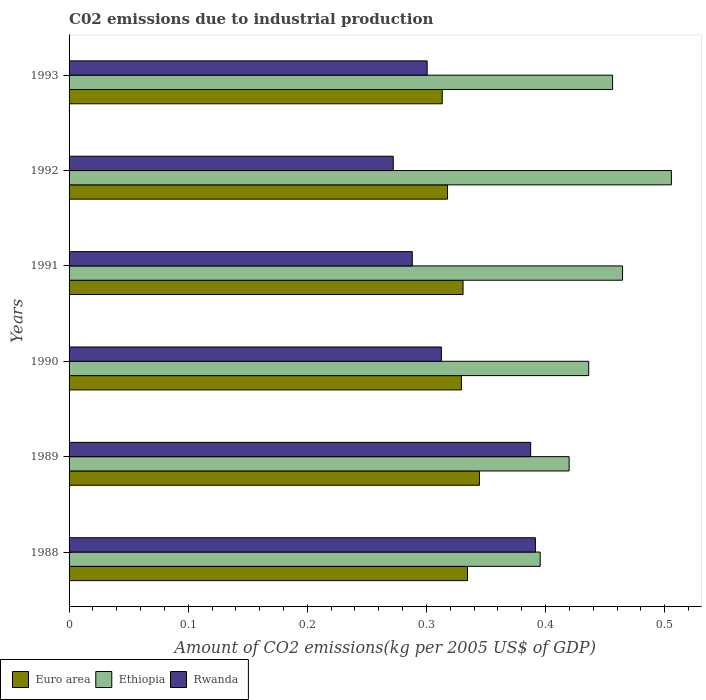How many groups of bars are there?
Provide a succinct answer. 6. Are the number of bars per tick equal to the number of legend labels?
Your answer should be very brief. Yes. Are the number of bars on each tick of the Y-axis equal?
Give a very brief answer. Yes. In how many cases, is the number of bars for a given year not equal to the number of legend labels?
Keep it short and to the point. 0. What is the amount of CO2 emitted due to industrial production in Euro area in 1992?
Offer a very short reply. 0.32. Across all years, what is the maximum amount of CO2 emitted due to industrial production in Rwanda?
Provide a succinct answer. 0.39. Across all years, what is the minimum amount of CO2 emitted due to industrial production in Euro area?
Your answer should be compact. 0.31. In which year was the amount of CO2 emitted due to industrial production in Ethiopia minimum?
Give a very brief answer. 1988. What is the total amount of CO2 emitted due to industrial production in Ethiopia in the graph?
Ensure brevity in your answer.  2.68. What is the difference between the amount of CO2 emitted due to industrial production in Ethiopia in 1989 and that in 1991?
Your response must be concise. -0.04. What is the difference between the amount of CO2 emitted due to industrial production in Ethiopia in 1991 and the amount of CO2 emitted due to industrial production in Euro area in 1989?
Your response must be concise. 0.12. What is the average amount of CO2 emitted due to industrial production in Euro area per year?
Keep it short and to the point. 0.33. In the year 1989, what is the difference between the amount of CO2 emitted due to industrial production in Euro area and amount of CO2 emitted due to industrial production in Rwanda?
Provide a succinct answer. -0.04. What is the ratio of the amount of CO2 emitted due to industrial production in Ethiopia in 1988 to that in 1991?
Provide a short and direct response. 0.85. Is the amount of CO2 emitted due to industrial production in Ethiopia in 1988 less than that in 1989?
Offer a very short reply. Yes. Is the difference between the amount of CO2 emitted due to industrial production in Euro area in 1988 and 1991 greater than the difference between the amount of CO2 emitted due to industrial production in Rwanda in 1988 and 1991?
Provide a succinct answer. No. What is the difference between the highest and the second highest amount of CO2 emitted due to industrial production in Rwanda?
Offer a terse response. 0. What is the difference between the highest and the lowest amount of CO2 emitted due to industrial production in Euro area?
Ensure brevity in your answer.  0.03. In how many years, is the amount of CO2 emitted due to industrial production in Ethiopia greater than the average amount of CO2 emitted due to industrial production in Ethiopia taken over all years?
Make the answer very short. 3. What does the 2nd bar from the bottom in 1989 represents?
Give a very brief answer. Ethiopia. Is it the case that in every year, the sum of the amount of CO2 emitted due to industrial production in Rwanda and amount of CO2 emitted due to industrial production in Ethiopia is greater than the amount of CO2 emitted due to industrial production in Euro area?
Ensure brevity in your answer.  Yes. How many bars are there?
Ensure brevity in your answer.  18. What is the difference between two consecutive major ticks on the X-axis?
Give a very brief answer. 0.1. Does the graph contain any zero values?
Provide a succinct answer. No. Does the graph contain grids?
Offer a very short reply. No. Where does the legend appear in the graph?
Offer a terse response. Bottom left. How many legend labels are there?
Provide a succinct answer. 3. What is the title of the graph?
Make the answer very short. C02 emissions due to industrial production. What is the label or title of the X-axis?
Your answer should be very brief. Amount of CO2 emissions(kg per 2005 US$ of GDP). What is the label or title of the Y-axis?
Offer a very short reply. Years. What is the Amount of CO2 emissions(kg per 2005 US$ of GDP) of Euro area in 1988?
Provide a short and direct response. 0.33. What is the Amount of CO2 emissions(kg per 2005 US$ of GDP) of Ethiopia in 1988?
Make the answer very short. 0.4. What is the Amount of CO2 emissions(kg per 2005 US$ of GDP) in Rwanda in 1988?
Give a very brief answer. 0.39. What is the Amount of CO2 emissions(kg per 2005 US$ of GDP) in Euro area in 1989?
Make the answer very short. 0.34. What is the Amount of CO2 emissions(kg per 2005 US$ of GDP) of Ethiopia in 1989?
Provide a succinct answer. 0.42. What is the Amount of CO2 emissions(kg per 2005 US$ of GDP) of Rwanda in 1989?
Provide a succinct answer. 0.39. What is the Amount of CO2 emissions(kg per 2005 US$ of GDP) in Euro area in 1990?
Your answer should be compact. 0.33. What is the Amount of CO2 emissions(kg per 2005 US$ of GDP) in Ethiopia in 1990?
Provide a succinct answer. 0.44. What is the Amount of CO2 emissions(kg per 2005 US$ of GDP) of Rwanda in 1990?
Offer a terse response. 0.31. What is the Amount of CO2 emissions(kg per 2005 US$ of GDP) of Euro area in 1991?
Keep it short and to the point. 0.33. What is the Amount of CO2 emissions(kg per 2005 US$ of GDP) in Ethiopia in 1991?
Provide a succinct answer. 0.46. What is the Amount of CO2 emissions(kg per 2005 US$ of GDP) of Rwanda in 1991?
Provide a short and direct response. 0.29. What is the Amount of CO2 emissions(kg per 2005 US$ of GDP) in Euro area in 1992?
Make the answer very short. 0.32. What is the Amount of CO2 emissions(kg per 2005 US$ of GDP) of Ethiopia in 1992?
Your answer should be compact. 0.51. What is the Amount of CO2 emissions(kg per 2005 US$ of GDP) of Rwanda in 1992?
Keep it short and to the point. 0.27. What is the Amount of CO2 emissions(kg per 2005 US$ of GDP) of Euro area in 1993?
Offer a terse response. 0.31. What is the Amount of CO2 emissions(kg per 2005 US$ of GDP) of Ethiopia in 1993?
Your response must be concise. 0.46. What is the Amount of CO2 emissions(kg per 2005 US$ of GDP) of Rwanda in 1993?
Your response must be concise. 0.3. Across all years, what is the maximum Amount of CO2 emissions(kg per 2005 US$ of GDP) in Euro area?
Your answer should be compact. 0.34. Across all years, what is the maximum Amount of CO2 emissions(kg per 2005 US$ of GDP) of Ethiopia?
Provide a succinct answer. 0.51. Across all years, what is the maximum Amount of CO2 emissions(kg per 2005 US$ of GDP) of Rwanda?
Provide a short and direct response. 0.39. Across all years, what is the minimum Amount of CO2 emissions(kg per 2005 US$ of GDP) in Euro area?
Your response must be concise. 0.31. Across all years, what is the minimum Amount of CO2 emissions(kg per 2005 US$ of GDP) of Ethiopia?
Provide a short and direct response. 0.4. Across all years, what is the minimum Amount of CO2 emissions(kg per 2005 US$ of GDP) in Rwanda?
Your answer should be compact. 0.27. What is the total Amount of CO2 emissions(kg per 2005 US$ of GDP) of Euro area in the graph?
Provide a succinct answer. 1.97. What is the total Amount of CO2 emissions(kg per 2005 US$ of GDP) of Ethiopia in the graph?
Offer a terse response. 2.68. What is the total Amount of CO2 emissions(kg per 2005 US$ of GDP) in Rwanda in the graph?
Keep it short and to the point. 1.95. What is the difference between the Amount of CO2 emissions(kg per 2005 US$ of GDP) of Euro area in 1988 and that in 1989?
Provide a succinct answer. -0.01. What is the difference between the Amount of CO2 emissions(kg per 2005 US$ of GDP) of Ethiopia in 1988 and that in 1989?
Give a very brief answer. -0.02. What is the difference between the Amount of CO2 emissions(kg per 2005 US$ of GDP) in Rwanda in 1988 and that in 1989?
Make the answer very short. 0. What is the difference between the Amount of CO2 emissions(kg per 2005 US$ of GDP) of Euro area in 1988 and that in 1990?
Ensure brevity in your answer.  0.01. What is the difference between the Amount of CO2 emissions(kg per 2005 US$ of GDP) of Ethiopia in 1988 and that in 1990?
Offer a terse response. -0.04. What is the difference between the Amount of CO2 emissions(kg per 2005 US$ of GDP) in Rwanda in 1988 and that in 1990?
Offer a terse response. 0.08. What is the difference between the Amount of CO2 emissions(kg per 2005 US$ of GDP) of Euro area in 1988 and that in 1991?
Your answer should be compact. 0. What is the difference between the Amount of CO2 emissions(kg per 2005 US$ of GDP) in Ethiopia in 1988 and that in 1991?
Provide a succinct answer. -0.07. What is the difference between the Amount of CO2 emissions(kg per 2005 US$ of GDP) of Rwanda in 1988 and that in 1991?
Offer a terse response. 0.1. What is the difference between the Amount of CO2 emissions(kg per 2005 US$ of GDP) in Euro area in 1988 and that in 1992?
Your answer should be compact. 0.02. What is the difference between the Amount of CO2 emissions(kg per 2005 US$ of GDP) of Ethiopia in 1988 and that in 1992?
Provide a succinct answer. -0.11. What is the difference between the Amount of CO2 emissions(kg per 2005 US$ of GDP) of Rwanda in 1988 and that in 1992?
Provide a succinct answer. 0.12. What is the difference between the Amount of CO2 emissions(kg per 2005 US$ of GDP) in Euro area in 1988 and that in 1993?
Keep it short and to the point. 0.02. What is the difference between the Amount of CO2 emissions(kg per 2005 US$ of GDP) of Ethiopia in 1988 and that in 1993?
Your answer should be very brief. -0.06. What is the difference between the Amount of CO2 emissions(kg per 2005 US$ of GDP) in Rwanda in 1988 and that in 1993?
Your answer should be compact. 0.09. What is the difference between the Amount of CO2 emissions(kg per 2005 US$ of GDP) in Euro area in 1989 and that in 1990?
Your response must be concise. 0.02. What is the difference between the Amount of CO2 emissions(kg per 2005 US$ of GDP) of Ethiopia in 1989 and that in 1990?
Provide a short and direct response. -0.02. What is the difference between the Amount of CO2 emissions(kg per 2005 US$ of GDP) in Rwanda in 1989 and that in 1990?
Your answer should be very brief. 0.07. What is the difference between the Amount of CO2 emissions(kg per 2005 US$ of GDP) of Euro area in 1989 and that in 1991?
Ensure brevity in your answer.  0.01. What is the difference between the Amount of CO2 emissions(kg per 2005 US$ of GDP) of Ethiopia in 1989 and that in 1991?
Provide a short and direct response. -0.04. What is the difference between the Amount of CO2 emissions(kg per 2005 US$ of GDP) of Rwanda in 1989 and that in 1991?
Ensure brevity in your answer.  0.1. What is the difference between the Amount of CO2 emissions(kg per 2005 US$ of GDP) in Euro area in 1989 and that in 1992?
Provide a short and direct response. 0.03. What is the difference between the Amount of CO2 emissions(kg per 2005 US$ of GDP) of Ethiopia in 1989 and that in 1992?
Give a very brief answer. -0.09. What is the difference between the Amount of CO2 emissions(kg per 2005 US$ of GDP) in Rwanda in 1989 and that in 1992?
Offer a very short reply. 0.12. What is the difference between the Amount of CO2 emissions(kg per 2005 US$ of GDP) of Euro area in 1989 and that in 1993?
Your answer should be very brief. 0.03. What is the difference between the Amount of CO2 emissions(kg per 2005 US$ of GDP) in Ethiopia in 1989 and that in 1993?
Your response must be concise. -0.04. What is the difference between the Amount of CO2 emissions(kg per 2005 US$ of GDP) in Rwanda in 1989 and that in 1993?
Offer a very short reply. 0.09. What is the difference between the Amount of CO2 emissions(kg per 2005 US$ of GDP) of Euro area in 1990 and that in 1991?
Make the answer very short. -0. What is the difference between the Amount of CO2 emissions(kg per 2005 US$ of GDP) in Ethiopia in 1990 and that in 1991?
Provide a short and direct response. -0.03. What is the difference between the Amount of CO2 emissions(kg per 2005 US$ of GDP) in Rwanda in 1990 and that in 1991?
Ensure brevity in your answer.  0.02. What is the difference between the Amount of CO2 emissions(kg per 2005 US$ of GDP) of Euro area in 1990 and that in 1992?
Provide a succinct answer. 0.01. What is the difference between the Amount of CO2 emissions(kg per 2005 US$ of GDP) in Ethiopia in 1990 and that in 1992?
Give a very brief answer. -0.07. What is the difference between the Amount of CO2 emissions(kg per 2005 US$ of GDP) in Rwanda in 1990 and that in 1992?
Keep it short and to the point. 0.04. What is the difference between the Amount of CO2 emissions(kg per 2005 US$ of GDP) of Euro area in 1990 and that in 1993?
Keep it short and to the point. 0.02. What is the difference between the Amount of CO2 emissions(kg per 2005 US$ of GDP) of Ethiopia in 1990 and that in 1993?
Offer a very short reply. -0.02. What is the difference between the Amount of CO2 emissions(kg per 2005 US$ of GDP) in Rwanda in 1990 and that in 1993?
Provide a succinct answer. 0.01. What is the difference between the Amount of CO2 emissions(kg per 2005 US$ of GDP) in Euro area in 1991 and that in 1992?
Offer a very short reply. 0.01. What is the difference between the Amount of CO2 emissions(kg per 2005 US$ of GDP) of Ethiopia in 1991 and that in 1992?
Provide a short and direct response. -0.04. What is the difference between the Amount of CO2 emissions(kg per 2005 US$ of GDP) of Rwanda in 1991 and that in 1992?
Make the answer very short. 0.02. What is the difference between the Amount of CO2 emissions(kg per 2005 US$ of GDP) of Euro area in 1991 and that in 1993?
Offer a terse response. 0.02. What is the difference between the Amount of CO2 emissions(kg per 2005 US$ of GDP) of Ethiopia in 1991 and that in 1993?
Provide a short and direct response. 0.01. What is the difference between the Amount of CO2 emissions(kg per 2005 US$ of GDP) in Rwanda in 1991 and that in 1993?
Provide a succinct answer. -0.01. What is the difference between the Amount of CO2 emissions(kg per 2005 US$ of GDP) of Euro area in 1992 and that in 1993?
Ensure brevity in your answer.  0. What is the difference between the Amount of CO2 emissions(kg per 2005 US$ of GDP) in Ethiopia in 1992 and that in 1993?
Provide a succinct answer. 0.05. What is the difference between the Amount of CO2 emissions(kg per 2005 US$ of GDP) of Rwanda in 1992 and that in 1993?
Your response must be concise. -0.03. What is the difference between the Amount of CO2 emissions(kg per 2005 US$ of GDP) of Euro area in 1988 and the Amount of CO2 emissions(kg per 2005 US$ of GDP) of Ethiopia in 1989?
Provide a short and direct response. -0.09. What is the difference between the Amount of CO2 emissions(kg per 2005 US$ of GDP) of Euro area in 1988 and the Amount of CO2 emissions(kg per 2005 US$ of GDP) of Rwanda in 1989?
Give a very brief answer. -0.05. What is the difference between the Amount of CO2 emissions(kg per 2005 US$ of GDP) of Ethiopia in 1988 and the Amount of CO2 emissions(kg per 2005 US$ of GDP) of Rwanda in 1989?
Your response must be concise. 0.01. What is the difference between the Amount of CO2 emissions(kg per 2005 US$ of GDP) in Euro area in 1988 and the Amount of CO2 emissions(kg per 2005 US$ of GDP) in Ethiopia in 1990?
Provide a succinct answer. -0.1. What is the difference between the Amount of CO2 emissions(kg per 2005 US$ of GDP) in Euro area in 1988 and the Amount of CO2 emissions(kg per 2005 US$ of GDP) in Rwanda in 1990?
Offer a very short reply. 0.02. What is the difference between the Amount of CO2 emissions(kg per 2005 US$ of GDP) in Ethiopia in 1988 and the Amount of CO2 emissions(kg per 2005 US$ of GDP) in Rwanda in 1990?
Offer a very short reply. 0.08. What is the difference between the Amount of CO2 emissions(kg per 2005 US$ of GDP) in Euro area in 1988 and the Amount of CO2 emissions(kg per 2005 US$ of GDP) in Ethiopia in 1991?
Offer a very short reply. -0.13. What is the difference between the Amount of CO2 emissions(kg per 2005 US$ of GDP) in Euro area in 1988 and the Amount of CO2 emissions(kg per 2005 US$ of GDP) in Rwanda in 1991?
Make the answer very short. 0.05. What is the difference between the Amount of CO2 emissions(kg per 2005 US$ of GDP) in Ethiopia in 1988 and the Amount of CO2 emissions(kg per 2005 US$ of GDP) in Rwanda in 1991?
Provide a short and direct response. 0.11. What is the difference between the Amount of CO2 emissions(kg per 2005 US$ of GDP) of Euro area in 1988 and the Amount of CO2 emissions(kg per 2005 US$ of GDP) of Ethiopia in 1992?
Provide a short and direct response. -0.17. What is the difference between the Amount of CO2 emissions(kg per 2005 US$ of GDP) in Euro area in 1988 and the Amount of CO2 emissions(kg per 2005 US$ of GDP) in Rwanda in 1992?
Your response must be concise. 0.06. What is the difference between the Amount of CO2 emissions(kg per 2005 US$ of GDP) in Ethiopia in 1988 and the Amount of CO2 emissions(kg per 2005 US$ of GDP) in Rwanda in 1992?
Provide a succinct answer. 0.12. What is the difference between the Amount of CO2 emissions(kg per 2005 US$ of GDP) in Euro area in 1988 and the Amount of CO2 emissions(kg per 2005 US$ of GDP) in Ethiopia in 1993?
Your answer should be very brief. -0.12. What is the difference between the Amount of CO2 emissions(kg per 2005 US$ of GDP) in Euro area in 1988 and the Amount of CO2 emissions(kg per 2005 US$ of GDP) in Rwanda in 1993?
Offer a terse response. 0.03. What is the difference between the Amount of CO2 emissions(kg per 2005 US$ of GDP) in Ethiopia in 1988 and the Amount of CO2 emissions(kg per 2005 US$ of GDP) in Rwanda in 1993?
Offer a terse response. 0.09. What is the difference between the Amount of CO2 emissions(kg per 2005 US$ of GDP) of Euro area in 1989 and the Amount of CO2 emissions(kg per 2005 US$ of GDP) of Ethiopia in 1990?
Your answer should be compact. -0.09. What is the difference between the Amount of CO2 emissions(kg per 2005 US$ of GDP) in Euro area in 1989 and the Amount of CO2 emissions(kg per 2005 US$ of GDP) in Rwanda in 1990?
Make the answer very short. 0.03. What is the difference between the Amount of CO2 emissions(kg per 2005 US$ of GDP) in Ethiopia in 1989 and the Amount of CO2 emissions(kg per 2005 US$ of GDP) in Rwanda in 1990?
Provide a short and direct response. 0.11. What is the difference between the Amount of CO2 emissions(kg per 2005 US$ of GDP) in Euro area in 1989 and the Amount of CO2 emissions(kg per 2005 US$ of GDP) in Ethiopia in 1991?
Your answer should be very brief. -0.12. What is the difference between the Amount of CO2 emissions(kg per 2005 US$ of GDP) in Euro area in 1989 and the Amount of CO2 emissions(kg per 2005 US$ of GDP) in Rwanda in 1991?
Your answer should be very brief. 0.06. What is the difference between the Amount of CO2 emissions(kg per 2005 US$ of GDP) in Ethiopia in 1989 and the Amount of CO2 emissions(kg per 2005 US$ of GDP) in Rwanda in 1991?
Your response must be concise. 0.13. What is the difference between the Amount of CO2 emissions(kg per 2005 US$ of GDP) of Euro area in 1989 and the Amount of CO2 emissions(kg per 2005 US$ of GDP) of Ethiopia in 1992?
Give a very brief answer. -0.16. What is the difference between the Amount of CO2 emissions(kg per 2005 US$ of GDP) of Euro area in 1989 and the Amount of CO2 emissions(kg per 2005 US$ of GDP) of Rwanda in 1992?
Your response must be concise. 0.07. What is the difference between the Amount of CO2 emissions(kg per 2005 US$ of GDP) in Ethiopia in 1989 and the Amount of CO2 emissions(kg per 2005 US$ of GDP) in Rwanda in 1992?
Offer a very short reply. 0.15. What is the difference between the Amount of CO2 emissions(kg per 2005 US$ of GDP) in Euro area in 1989 and the Amount of CO2 emissions(kg per 2005 US$ of GDP) in Ethiopia in 1993?
Keep it short and to the point. -0.11. What is the difference between the Amount of CO2 emissions(kg per 2005 US$ of GDP) of Euro area in 1989 and the Amount of CO2 emissions(kg per 2005 US$ of GDP) of Rwanda in 1993?
Your response must be concise. 0.04. What is the difference between the Amount of CO2 emissions(kg per 2005 US$ of GDP) in Ethiopia in 1989 and the Amount of CO2 emissions(kg per 2005 US$ of GDP) in Rwanda in 1993?
Your response must be concise. 0.12. What is the difference between the Amount of CO2 emissions(kg per 2005 US$ of GDP) of Euro area in 1990 and the Amount of CO2 emissions(kg per 2005 US$ of GDP) of Ethiopia in 1991?
Ensure brevity in your answer.  -0.14. What is the difference between the Amount of CO2 emissions(kg per 2005 US$ of GDP) of Euro area in 1990 and the Amount of CO2 emissions(kg per 2005 US$ of GDP) of Rwanda in 1991?
Your answer should be very brief. 0.04. What is the difference between the Amount of CO2 emissions(kg per 2005 US$ of GDP) of Ethiopia in 1990 and the Amount of CO2 emissions(kg per 2005 US$ of GDP) of Rwanda in 1991?
Provide a short and direct response. 0.15. What is the difference between the Amount of CO2 emissions(kg per 2005 US$ of GDP) of Euro area in 1990 and the Amount of CO2 emissions(kg per 2005 US$ of GDP) of Ethiopia in 1992?
Keep it short and to the point. -0.18. What is the difference between the Amount of CO2 emissions(kg per 2005 US$ of GDP) of Euro area in 1990 and the Amount of CO2 emissions(kg per 2005 US$ of GDP) of Rwanda in 1992?
Give a very brief answer. 0.06. What is the difference between the Amount of CO2 emissions(kg per 2005 US$ of GDP) of Ethiopia in 1990 and the Amount of CO2 emissions(kg per 2005 US$ of GDP) of Rwanda in 1992?
Offer a very short reply. 0.16. What is the difference between the Amount of CO2 emissions(kg per 2005 US$ of GDP) in Euro area in 1990 and the Amount of CO2 emissions(kg per 2005 US$ of GDP) in Ethiopia in 1993?
Make the answer very short. -0.13. What is the difference between the Amount of CO2 emissions(kg per 2005 US$ of GDP) in Euro area in 1990 and the Amount of CO2 emissions(kg per 2005 US$ of GDP) in Rwanda in 1993?
Give a very brief answer. 0.03. What is the difference between the Amount of CO2 emissions(kg per 2005 US$ of GDP) of Ethiopia in 1990 and the Amount of CO2 emissions(kg per 2005 US$ of GDP) of Rwanda in 1993?
Ensure brevity in your answer.  0.14. What is the difference between the Amount of CO2 emissions(kg per 2005 US$ of GDP) of Euro area in 1991 and the Amount of CO2 emissions(kg per 2005 US$ of GDP) of Ethiopia in 1992?
Give a very brief answer. -0.17. What is the difference between the Amount of CO2 emissions(kg per 2005 US$ of GDP) of Euro area in 1991 and the Amount of CO2 emissions(kg per 2005 US$ of GDP) of Rwanda in 1992?
Offer a terse response. 0.06. What is the difference between the Amount of CO2 emissions(kg per 2005 US$ of GDP) of Ethiopia in 1991 and the Amount of CO2 emissions(kg per 2005 US$ of GDP) of Rwanda in 1992?
Offer a terse response. 0.19. What is the difference between the Amount of CO2 emissions(kg per 2005 US$ of GDP) of Euro area in 1991 and the Amount of CO2 emissions(kg per 2005 US$ of GDP) of Ethiopia in 1993?
Give a very brief answer. -0.13. What is the difference between the Amount of CO2 emissions(kg per 2005 US$ of GDP) of Euro area in 1991 and the Amount of CO2 emissions(kg per 2005 US$ of GDP) of Rwanda in 1993?
Your answer should be compact. 0.03. What is the difference between the Amount of CO2 emissions(kg per 2005 US$ of GDP) of Ethiopia in 1991 and the Amount of CO2 emissions(kg per 2005 US$ of GDP) of Rwanda in 1993?
Ensure brevity in your answer.  0.16. What is the difference between the Amount of CO2 emissions(kg per 2005 US$ of GDP) in Euro area in 1992 and the Amount of CO2 emissions(kg per 2005 US$ of GDP) in Ethiopia in 1993?
Provide a succinct answer. -0.14. What is the difference between the Amount of CO2 emissions(kg per 2005 US$ of GDP) in Euro area in 1992 and the Amount of CO2 emissions(kg per 2005 US$ of GDP) in Rwanda in 1993?
Provide a succinct answer. 0.02. What is the difference between the Amount of CO2 emissions(kg per 2005 US$ of GDP) in Ethiopia in 1992 and the Amount of CO2 emissions(kg per 2005 US$ of GDP) in Rwanda in 1993?
Offer a terse response. 0.2. What is the average Amount of CO2 emissions(kg per 2005 US$ of GDP) in Euro area per year?
Provide a succinct answer. 0.33. What is the average Amount of CO2 emissions(kg per 2005 US$ of GDP) in Ethiopia per year?
Give a very brief answer. 0.45. What is the average Amount of CO2 emissions(kg per 2005 US$ of GDP) of Rwanda per year?
Your answer should be compact. 0.33. In the year 1988, what is the difference between the Amount of CO2 emissions(kg per 2005 US$ of GDP) in Euro area and Amount of CO2 emissions(kg per 2005 US$ of GDP) in Ethiopia?
Offer a very short reply. -0.06. In the year 1988, what is the difference between the Amount of CO2 emissions(kg per 2005 US$ of GDP) in Euro area and Amount of CO2 emissions(kg per 2005 US$ of GDP) in Rwanda?
Give a very brief answer. -0.06. In the year 1988, what is the difference between the Amount of CO2 emissions(kg per 2005 US$ of GDP) of Ethiopia and Amount of CO2 emissions(kg per 2005 US$ of GDP) of Rwanda?
Your response must be concise. 0. In the year 1989, what is the difference between the Amount of CO2 emissions(kg per 2005 US$ of GDP) in Euro area and Amount of CO2 emissions(kg per 2005 US$ of GDP) in Ethiopia?
Provide a succinct answer. -0.08. In the year 1989, what is the difference between the Amount of CO2 emissions(kg per 2005 US$ of GDP) of Euro area and Amount of CO2 emissions(kg per 2005 US$ of GDP) of Rwanda?
Your answer should be compact. -0.04. In the year 1989, what is the difference between the Amount of CO2 emissions(kg per 2005 US$ of GDP) in Ethiopia and Amount of CO2 emissions(kg per 2005 US$ of GDP) in Rwanda?
Make the answer very short. 0.03. In the year 1990, what is the difference between the Amount of CO2 emissions(kg per 2005 US$ of GDP) of Euro area and Amount of CO2 emissions(kg per 2005 US$ of GDP) of Ethiopia?
Your answer should be compact. -0.11. In the year 1990, what is the difference between the Amount of CO2 emissions(kg per 2005 US$ of GDP) in Euro area and Amount of CO2 emissions(kg per 2005 US$ of GDP) in Rwanda?
Your response must be concise. 0.02. In the year 1990, what is the difference between the Amount of CO2 emissions(kg per 2005 US$ of GDP) in Ethiopia and Amount of CO2 emissions(kg per 2005 US$ of GDP) in Rwanda?
Your answer should be very brief. 0.12. In the year 1991, what is the difference between the Amount of CO2 emissions(kg per 2005 US$ of GDP) of Euro area and Amount of CO2 emissions(kg per 2005 US$ of GDP) of Ethiopia?
Offer a very short reply. -0.13. In the year 1991, what is the difference between the Amount of CO2 emissions(kg per 2005 US$ of GDP) in Euro area and Amount of CO2 emissions(kg per 2005 US$ of GDP) in Rwanda?
Provide a short and direct response. 0.04. In the year 1991, what is the difference between the Amount of CO2 emissions(kg per 2005 US$ of GDP) in Ethiopia and Amount of CO2 emissions(kg per 2005 US$ of GDP) in Rwanda?
Offer a terse response. 0.18. In the year 1992, what is the difference between the Amount of CO2 emissions(kg per 2005 US$ of GDP) of Euro area and Amount of CO2 emissions(kg per 2005 US$ of GDP) of Ethiopia?
Your response must be concise. -0.19. In the year 1992, what is the difference between the Amount of CO2 emissions(kg per 2005 US$ of GDP) in Euro area and Amount of CO2 emissions(kg per 2005 US$ of GDP) in Rwanda?
Offer a very short reply. 0.05. In the year 1992, what is the difference between the Amount of CO2 emissions(kg per 2005 US$ of GDP) of Ethiopia and Amount of CO2 emissions(kg per 2005 US$ of GDP) of Rwanda?
Offer a very short reply. 0.23. In the year 1993, what is the difference between the Amount of CO2 emissions(kg per 2005 US$ of GDP) in Euro area and Amount of CO2 emissions(kg per 2005 US$ of GDP) in Ethiopia?
Your response must be concise. -0.14. In the year 1993, what is the difference between the Amount of CO2 emissions(kg per 2005 US$ of GDP) in Euro area and Amount of CO2 emissions(kg per 2005 US$ of GDP) in Rwanda?
Give a very brief answer. 0.01. In the year 1993, what is the difference between the Amount of CO2 emissions(kg per 2005 US$ of GDP) in Ethiopia and Amount of CO2 emissions(kg per 2005 US$ of GDP) in Rwanda?
Your answer should be compact. 0.16. What is the ratio of the Amount of CO2 emissions(kg per 2005 US$ of GDP) of Euro area in 1988 to that in 1989?
Offer a very short reply. 0.97. What is the ratio of the Amount of CO2 emissions(kg per 2005 US$ of GDP) in Ethiopia in 1988 to that in 1989?
Offer a terse response. 0.94. What is the ratio of the Amount of CO2 emissions(kg per 2005 US$ of GDP) of Rwanda in 1988 to that in 1989?
Provide a succinct answer. 1.01. What is the ratio of the Amount of CO2 emissions(kg per 2005 US$ of GDP) in Euro area in 1988 to that in 1990?
Your answer should be very brief. 1.02. What is the ratio of the Amount of CO2 emissions(kg per 2005 US$ of GDP) in Ethiopia in 1988 to that in 1990?
Provide a short and direct response. 0.91. What is the ratio of the Amount of CO2 emissions(kg per 2005 US$ of GDP) of Rwanda in 1988 to that in 1990?
Your response must be concise. 1.25. What is the ratio of the Amount of CO2 emissions(kg per 2005 US$ of GDP) in Euro area in 1988 to that in 1991?
Offer a very short reply. 1.01. What is the ratio of the Amount of CO2 emissions(kg per 2005 US$ of GDP) of Ethiopia in 1988 to that in 1991?
Your answer should be compact. 0.85. What is the ratio of the Amount of CO2 emissions(kg per 2005 US$ of GDP) of Rwanda in 1988 to that in 1991?
Provide a succinct answer. 1.36. What is the ratio of the Amount of CO2 emissions(kg per 2005 US$ of GDP) in Euro area in 1988 to that in 1992?
Your answer should be compact. 1.05. What is the ratio of the Amount of CO2 emissions(kg per 2005 US$ of GDP) in Ethiopia in 1988 to that in 1992?
Provide a succinct answer. 0.78. What is the ratio of the Amount of CO2 emissions(kg per 2005 US$ of GDP) in Rwanda in 1988 to that in 1992?
Provide a succinct answer. 1.44. What is the ratio of the Amount of CO2 emissions(kg per 2005 US$ of GDP) in Euro area in 1988 to that in 1993?
Your answer should be compact. 1.07. What is the ratio of the Amount of CO2 emissions(kg per 2005 US$ of GDP) in Ethiopia in 1988 to that in 1993?
Your response must be concise. 0.87. What is the ratio of the Amount of CO2 emissions(kg per 2005 US$ of GDP) in Rwanda in 1988 to that in 1993?
Provide a short and direct response. 1.3. What is the ratio of the Amount of CO2 emissions(kg per 2005 US$ of GDP) in Euro area in 1989 to that in 1990?
Your answer should be very brief. 1.05. What is the ratio of the Amount of CO2 emissions(kg per 2005 US$ of GDP) in Ethiopia in 1989 to that in 1990?
Offer a very short reply. 0.96. What is the ratio of the Amount of CO2 emissions(kg per 2005 US$ of GDP) of Rwanda in 1989 to that in 1990?
Offer a terse response. 1.24. What is the ratio of the Amount of CO2 emissions(kg per 2005 US$ of GDP) of Euro area in 1989 to that in 1991?
Provide a short and direct response. 1.04. What is the ratio of the Amount of CO2 emissions(kg per 2005 US$ of GDP) of Ethiopia in 1989 to that in 1991?
Provide a succinct answer. 0.9. What is the ratio of the Amount of CO2 emissions(kg per 2005 US$ of GDP) of Rwanda in 1989 to that in 1991?
Your answer should be very brief. 1.34. What is the ratio of the Amount of CO2 emissions(kg per 2005 US$ of GDP) in Euro area in 1989 to that in 1992?
Provide a succinct answer. 1.08. What is the ratio of the Amount of CO2 emissions(kg per 2005 US$ of GDP) of Ethiopia in 1989 to that in 1992?
Provide a short and direct response. 0.83. What is the ratio of the Amount of CO2 emissions(kg per 2005 US$ of GDP) in Rwanda in 1989 to that in 1992?
Provide a short and direct response. 1.42. What is the ratio of the Amount of CO2 emissions(kg per 2005 US$ of GDP) in Euro area in 1989 to that in 1993?
Provide a succinct answer. 1.1. What is the ratio of the Amount of CO2 emissions(kg per 2005 US$ of GDP) in Ethiopia in 1989 to that in 1993?
Provide a short and direct response. 0.92. What is the ratio of the Amount of CO2 emissions(kg per 2005 US$ of GDP) in Rwanda in 1989 to that in 1993?
Offer a terse response. 1.29. What is the ratio of the Amount of CO2 emissions(kg per 2005 US$ of GDP) of Ethiopia in 1990 to that in 1991?
Offer a terse response. 0.94. What is the ratio of the Amount of CO2 emissions(kg per 2005 US$ of GDP) of Rwanda in 1990 to that in 1991?
Offer a terse response. 1.08. What is the ratio of the Amount of CO2 emissions(kg per 2005 US$ of GDP) of Euro area in 1990 to that in 1992?
Provide a short and direct response. 1.04. What is the ratio of the Amount of CO2 emissions(kg per 2005 US$ of GDP) of Ethiopia in 1990 to that in 1992?
Your response must be concise. 0.86. What is the ratio of the Amount of CO2 emissions(kg per 2005 US$ of GDP) in Rwanda in 1990 to that in 1992?
Give a very brief answer. 1.15. What is the ratio of the Amount of CO2 emissions(kg per 2005 US$ of GDP) of Euro area in 1990 to that in 1993?
Your answer should be very brief. 1.05. What is the ratio of the Amount of CO2 emissions(kg per 2005 US$ of GDP) of Ethiopia in 1990 to that in 1993?
Provide a succinct answer. 0.96. What is the ratio of the Amount of CO2 emissions(kg per 2005 US$ of GDP) of Rwanda in 1990 to that in 1993?
Give a very brief answer. 1.04. What is the ratio of the Amount of CO2 emissions(kg per 2005 US$ of GDP) of Euro area in 1991 to that in 1992?
Your answer should be very brief. 1.04. What is the ratio of the Amount of CO2 emissions(kg per 2005 US$ of GDP) of Ethiopia in 1991 to that in 1992?
Your answer should be compact. 0.92. What is the ratio of the Amount of CO2 emissions(kg per 2005 US$ of GDP) of Rwanda in 1991 to that in 1992?
Provide a short and direct response. 1.06. What is the ratio of the Amount of CO2 emissions(kg per 2005 US$ of GDP) of Euro area in 1991 to that in 1993?
Your answer should be compact. 1.06. What is the ratio of the Amount of CO2 emissions(kg per 2005 US$ of GDP) of Ethiopia in 1991 to that in 1993?
Offer a very short reply. 1.02. What is the ratio of the Amount of CO2 emissions(kg per 2005 US$ of GDP) in Rwanda in 1991 to that in 1993?
Offer a very short reply. 0.96. What is the ratio of the Amount of CO2 emissions(kg per 2005 US$ of GDP) in Euro area in 1992 to that in 1993?
Give a very brief answer. 1.01. What is the ratio of the Amount of CO2 emissions(kg per 2005 US$ of GDP) in Ethiopia in 1992 to that in 1993?
Your answer should be compact. 1.11. What is the ratio of the Amount of CO2 emissions(kg per 2005 US$ of GDP) in Rwanda in 1992 to that in 1993?
Offer a terse response. 0.91. What is the difference between the highest and the second highest Amount of CO2 emissions(kg per 2005 US$ of GDP) of Euro area?
Offer a terse response. 0.01. What is the difference between the highest and the second highest Amount of CO2 emissions(kg per 2005 US$ of GDP) in Ethiopia?
Offer a very short reply. 0.04. What is the difference between the highest and the second highest Amount of CO2 emissions(kg per 2005 US$ of GDP) of Rwanda?
Provide a succinct answer. 0. What is the difference between the highest and the lowest Amount of CO2 emissions(kg per 2005 US$ of GDP) of Euro area?
Ensure brevity in your answer.  0.03. What is the difference between the highest and the lowest Amount of CO2 emissions(kg per 2005 US$ of GDP) of Ethiopia?
Provide a succinct answer. 0.11. What is the difference between the highest and the lowest Amount of CO2 emissions(kg per 2005 US$ of GDP) of Rwanda?
Provide a short and direct response. 0.12. 